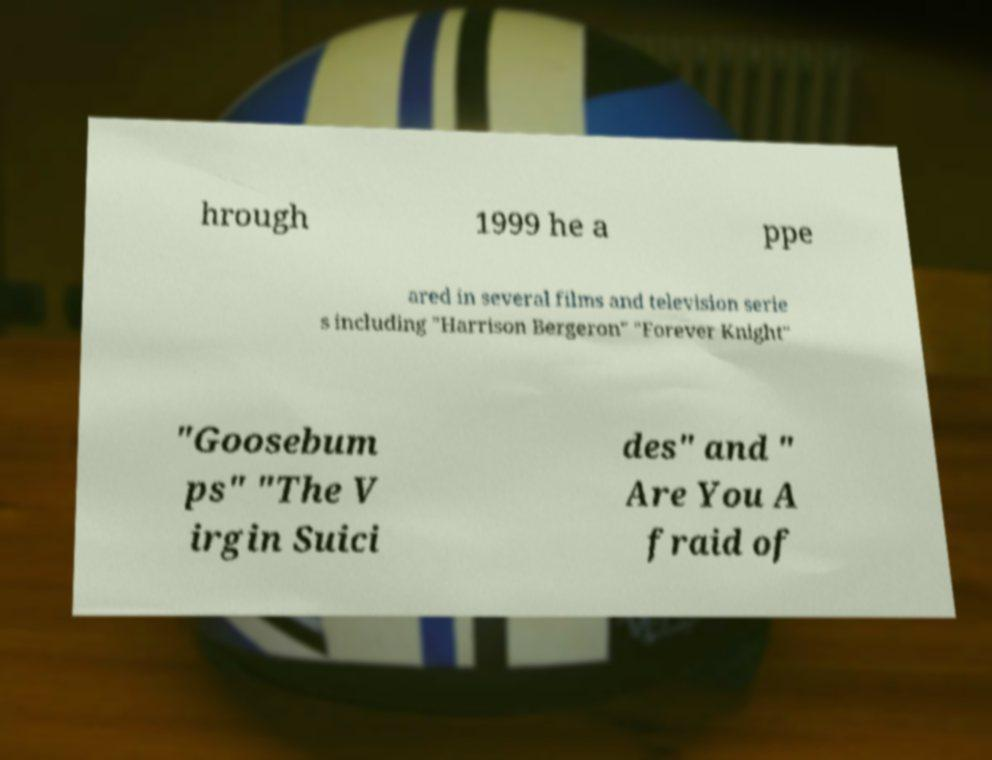Please read and relay the text visible in this image. What does it say? hrough 1999 he a ppe ared in several films and television serie s including "Harrison Bergeron" "Forever Knight" "Goosebum ps" "The V irgin Suici des" and " Are You A fraid of 